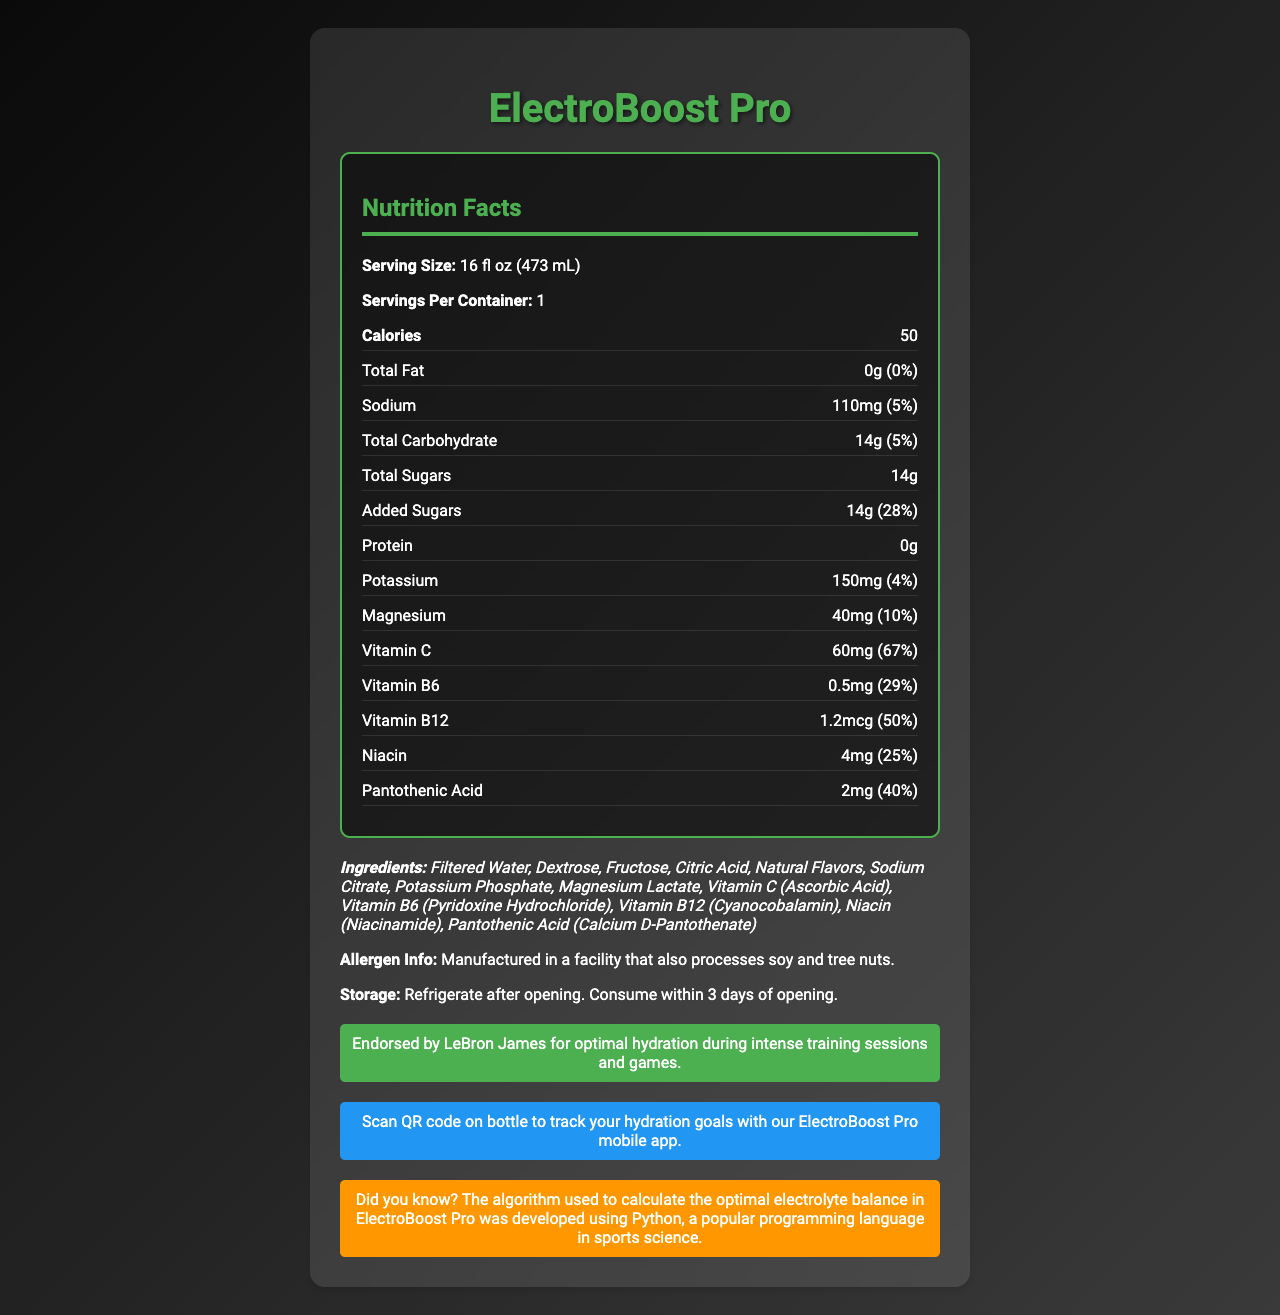what is the serving size of ElectroBoost Pro? The serving size is listed as 16 fl oz (473 mL) on the document.
Answer: 16 fl oz (473 mL) how many calories are in one serving of ElectroBoost Pro? The document states that one serving has 50 calories.
Answer: 50 what percentage of the daily value is the added sugars in ElectroBoost Pro? The document shows that the added sugars account for 28% of the daily value.
Answer: 28% how much vitamin C is in a serving of ElectroBoost Pro? The document mentions that a serving contains 60mg of Vitamin C, which is 67% of the daily value.
Answer: 60mg does ElectroBoost Pro contain any protein? The document states that the protein content is 0g.
Answer: No which athlete endorses ElectroBoost Pro? The document includes an athlete endorsement by LeBron James for optimal hydration during intense training sessions and games.
Answer: LeBron James what are the total carbohydrates in ElectroBoost Pro? A. 0g B. 5g C. 14g D. 28g According to the document, the total carbohydrate content is 14g.
Answer: C. 14g which vitamin has the highest percentage of the daily value in ElectroBoost Pro? A. Vitamin C B. Vitamin B6 C. Vitamin B12 D. Pantothenic Acid The document indicates that Vitamin C has the highest percentage of the daily value, at 67%.
Answer: A. Vitamin C are there any allergens listed in the manufacturing information? The document states that the product is manufactured in a facility that also processes soy and tree nuts.
Answer: Yes is ElectroBoost Pro suitable for someone avoiding fat in their diet? The document indicates that the total fat content is 0g, which is 0% of the daily value.
Answer: Yes summarize the main features of ElectroBoost Pro as shown in the document. The document provides a comprehensive overview of ElectroBoost Pro, including its nutrition facts, key ingredients, endorsement by LeBron James, storage instructions, allergen information, and tech integration for tracking hydration.
Answer: ElectroBoost Pro is a vitamin-fortified sports drink with a focus on hydration and endurance. It contains 50 calories per serving, with key nutrients such as sodium, potassium, magnesium, vitamin C, and B vitamins. Endorsed by LeBron James, it supports endurance and rapid rehydration. The drink is manufactured in a facility that processes soy and tree nuts and should be refrigerated and consumed within 3 days of opening. It also integrates a mobile app for tracking hydration goals. can you determine the expiration date of ElectroBoost Pro from the document? The document does not provide any information regarding the expiration date of the product.
Answer: Cannot be determined 